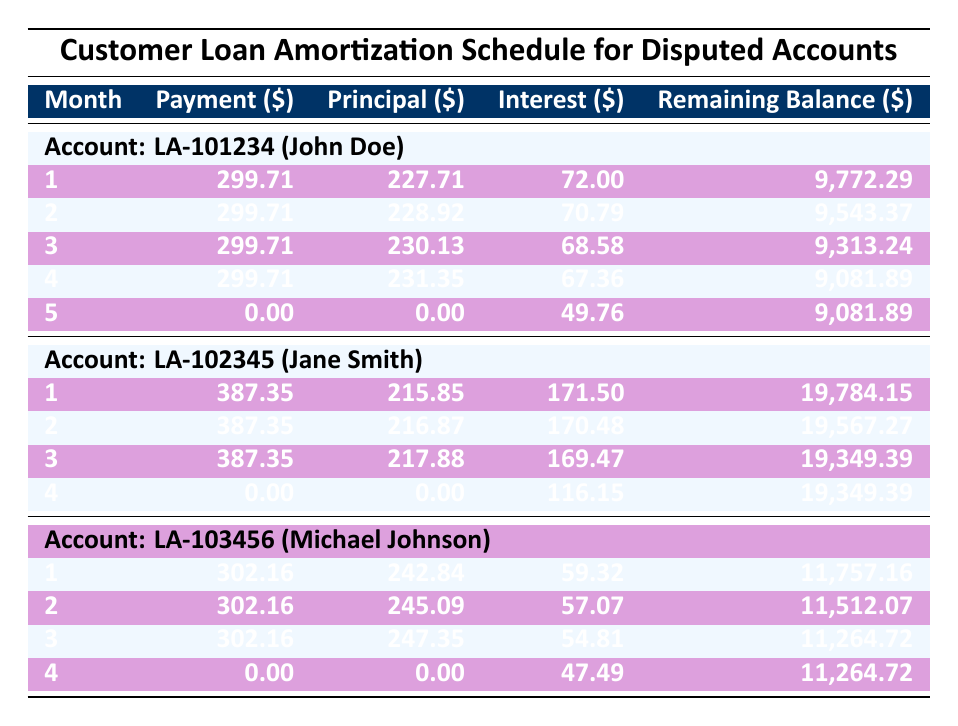What is the monthly payment amount for John Doe? The monthly payment for John Doe in account LA-101234 is listed directly in the table as 299.71.
Answer: 299.71 How much interest did Jane Smith pay in the second month? In the table, for account LA-102345, the interest paid by Jane Smith in the second month is recorded as 170.48.
Answer: 170.48 What is the remaining balance after Michael Johnson's third payment? According to the table, after Michael Johnson's third payment, the remaining balance for account LA-103456 is 11,264.72, which is visible in the month 3 row.
Answer: 11,264.72 Did John Doe make any payment in the fifth month? The table indicates that John Doe made a payment of 0.00 in the fifth month for account LA-101234. Therefore, the answer is yes, he did not make a payment.
Answer: No What is the total principal paid by Jane Smith in the first three months? To find the total principal paid by Jane Smith, I will add up the principal amounts from months 1, 2, and 3. This is calculated as 215.85 + 216.87 + 217.88 = 650.60.
Answer: 650.60 Which customer has the highest disputed amount? By examining the disputed amounts listed for each customer, John Doe has a disputed amount of 1500.00, Jane Smith has 3000.00, and Michael Johnson has 1200.00. Therefore, Jane Smith has the highest disputed amount.
Answer: Jane Smith What is the average payment amount made by Michael Johnson over the first three months? The total payments made by Michael Johnson in the first three months are 302.16 for each month, giving a total of 302.16 * 3 = 906.48. To find the average, divide this total by 3: 906.48 / 3 = 302.16.
Answer: 302.16 How many months did Jane Smith make a payment? Reviewing the payment history for Jane Smith, she made payments in months 1, 2, and 3 but not in month 4. Hence, she made payments for a total of 3 months.
Answer: 3 months After month 4, what was the remaining balance of John Doe? The remaining balance for John Doe after month 4 is listed as 9,081.89 in the table.
Answer: 9,081.89 